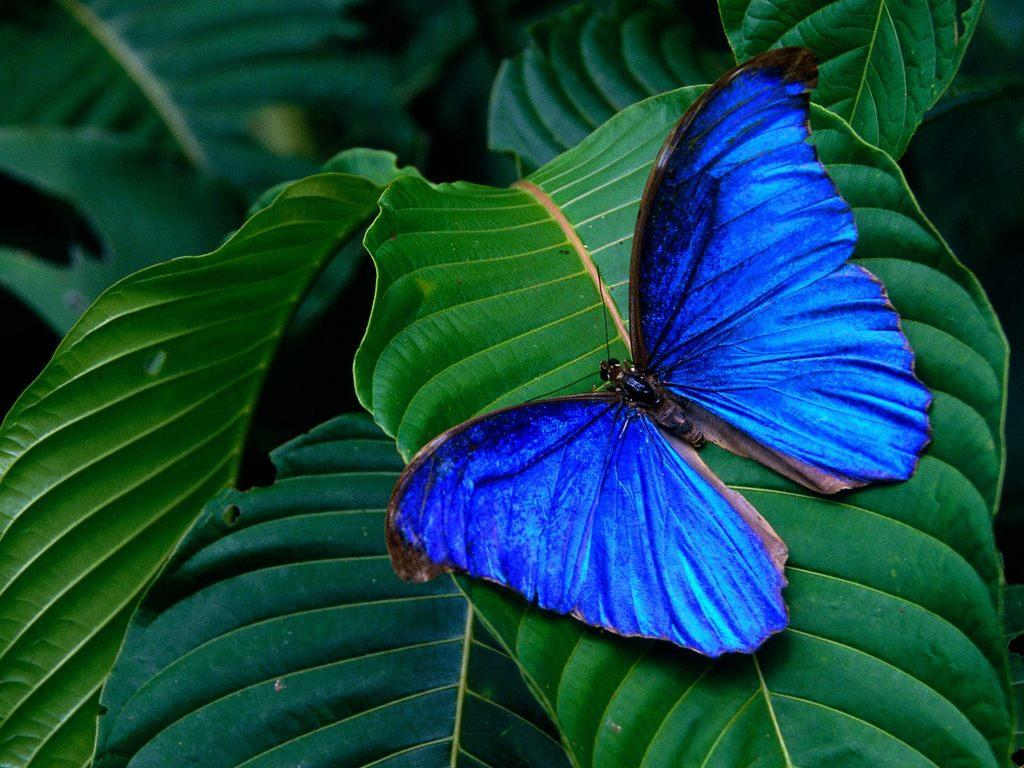What type of insect is present in the image? There is a blue color butterfly in the image. Where is the butterfly located? The butterfly is on a leaf. How many flowers are on the wrist of the butterfly in the image? There are no flowers present in the image, and the butterfly does not have a wrist. 